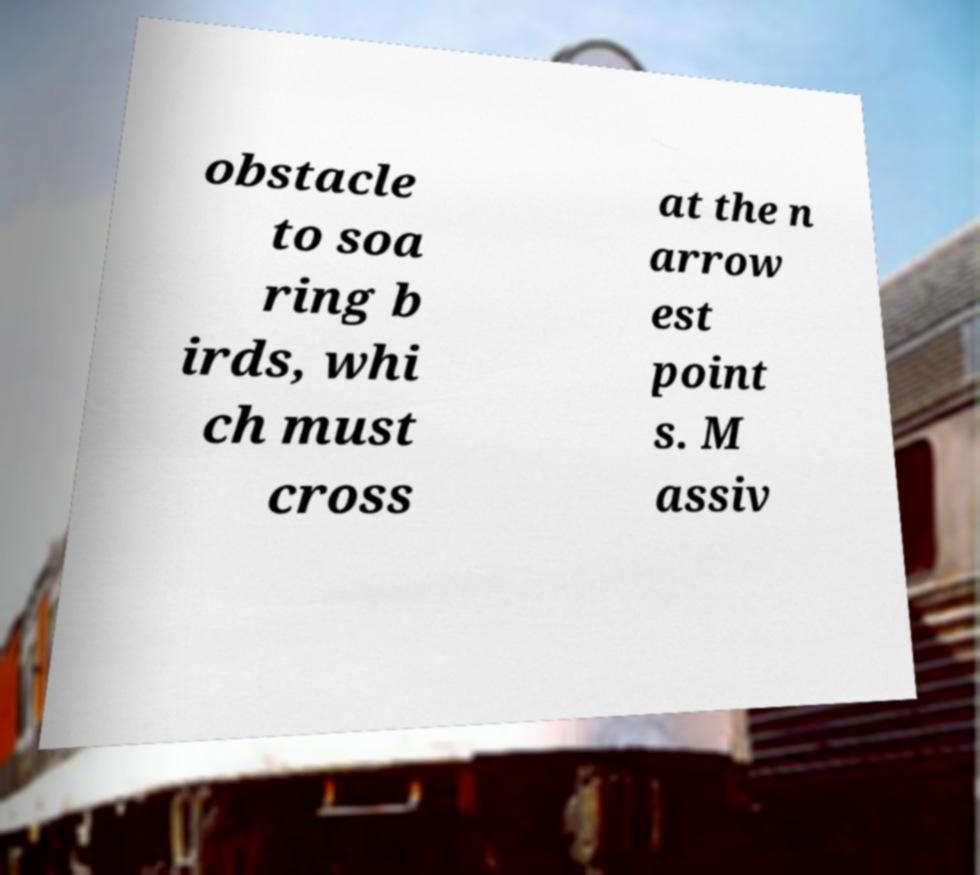Can you accurately transcribe the text from the provided image for me? obstacle to soa ring b irds, whi ch must cross at the n arrow est point s. M assiv 